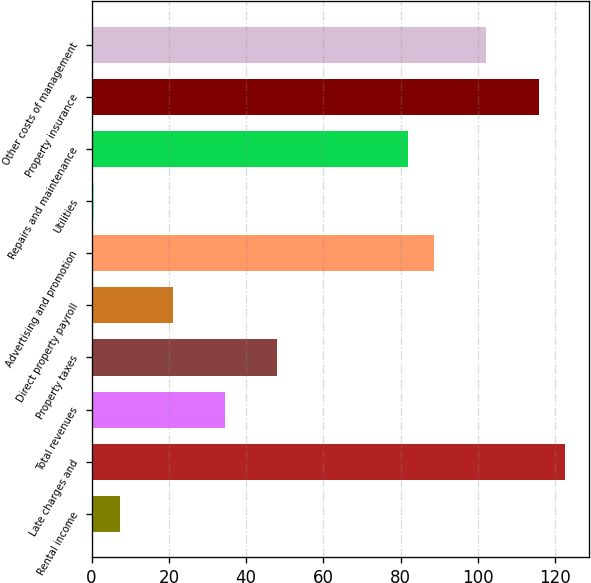Convert chart. <chart><loc_0><loc_0><loc_500><loc_500><bar_chart><fcel>Rental income<fcel>Late charges and<fcel>Total revenues<fcel>Property taxes<fcel>Direct property payroll<fcel>Advertising and promotion<fcel>Utilities<fcel>Repairs and maintenance<fcel>Property insurance<fcel>Other costs of management<nl><fcel>7.47<fcel>122.56<fcel>34.55<fcel>48.09<fcel>21.01<fcel>88.71<fcel>0.7<fcel>81.94<fcel>115.79<fcel>102.25<nl></chart> 